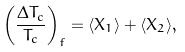Convert formula to latex. <formula><loc_0><loc_0><loc_500><loc_500>\left ( \frac { \Delta T _ { c } } { T _ { c } } \right ) _ { f } = \langle X _ { 1 } \rangle + \langle X _ { 2 } \rangle ,</formula> 